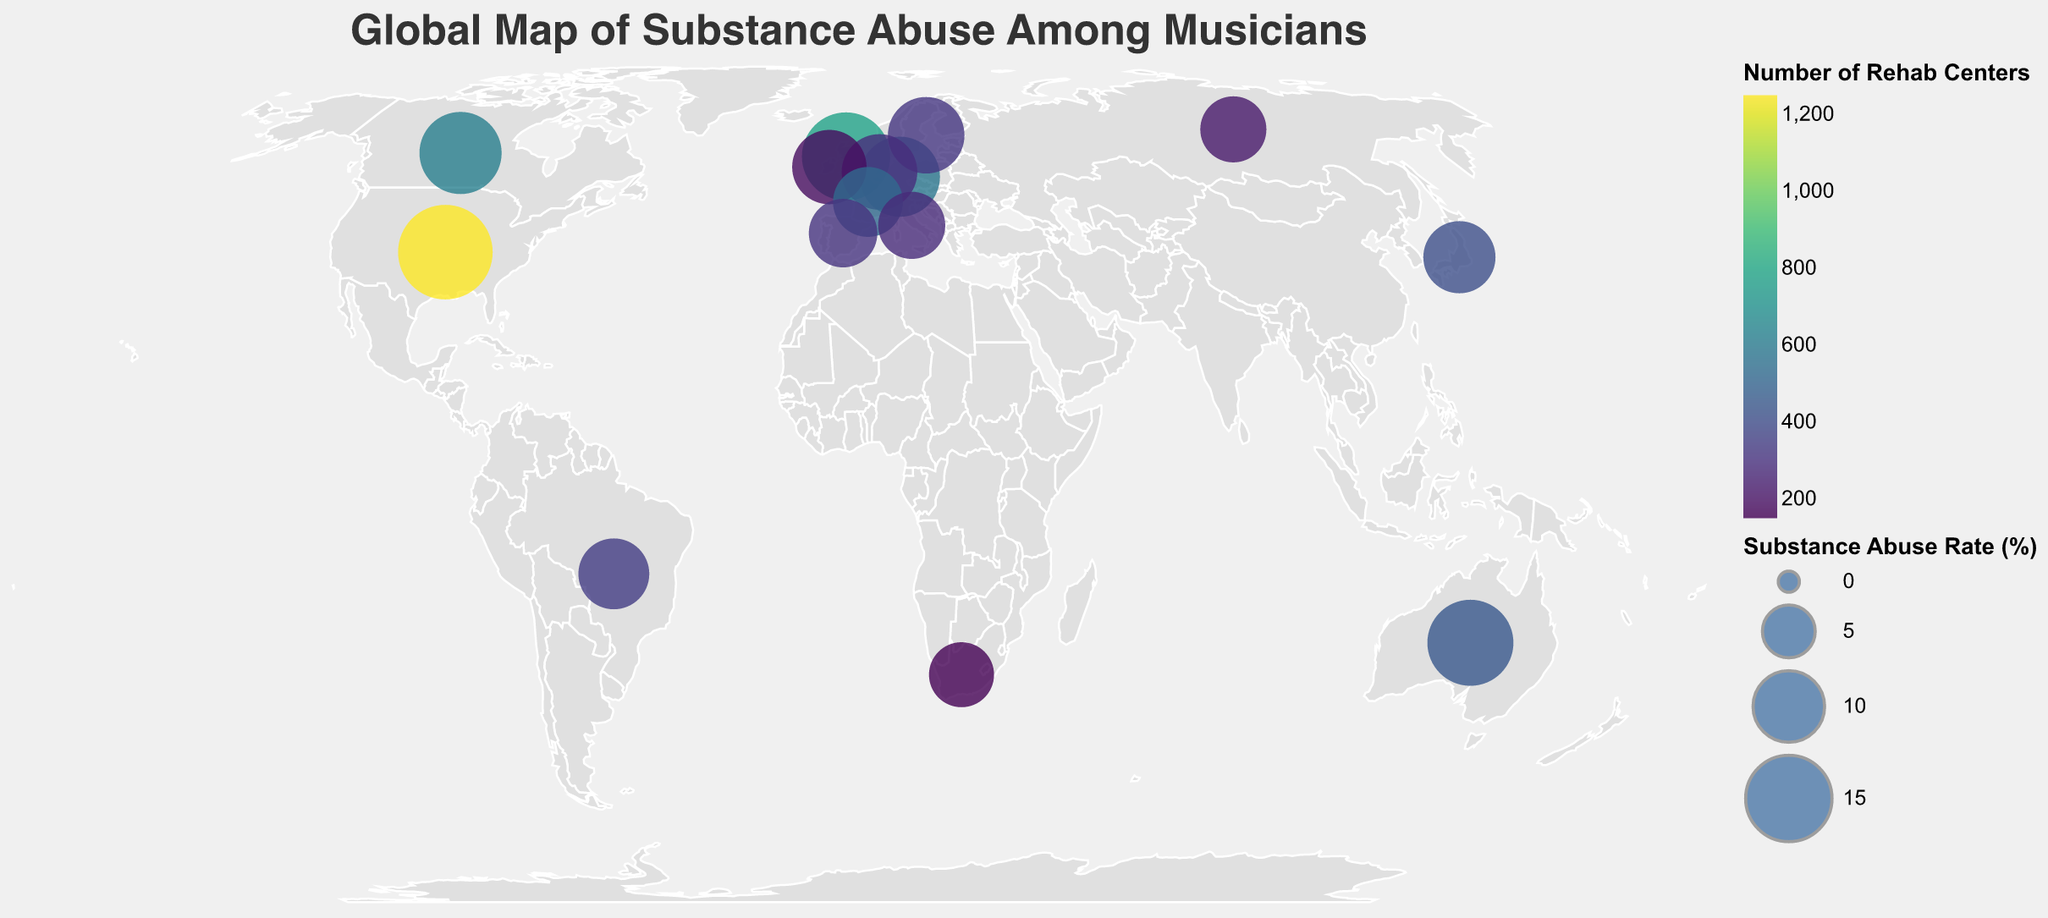What is the title of the figure? The title is usually located at the top of the figure, and it is meant to provide a concise summary of what the figure represents. Look at the top center to find it.
Answer: Global Map of Substance Abuse Among Musicians Which country has the highest substance abuse rate among musicians? Identify the country with the largest circle, which represents a higher substance abuse rate. The tooltip provides detailed information when hovering over each circle.
Answer: United States How many rehab centers are there in Germany according to the map? Find Germany on the map, hover over or refer to its circle to see the tooltip, which lists the number of rehab centers along with other details.
Answer: 580 Compare the substance abuse rates of the United Kingdom and Australia. Which country has a higher rate? Look at the circle sizes for both the United Kingdom and Australia. Refer to the tooltip for precise values if needed.
Answer: United Kingdom What is the relationship between the number of rehab centers and substance abuse rate in the United States? Observe the tooltip for the circle representing the United States to check both the substance abuse rate and the number of rehab centers, and analyze if there is any visible correlation.
Answer: The United States has a high substance abuse rate (18.2%) and a large number of rehab centers (1250) Which region (Europe or Americas) has a higher average substance abuse rate among musicians based on the given countries? Identify the countries in the data that belong to Europe (UK, Germany, Sweden, Netherlands, Ireland, France, Spain, Italy, Russia) and the Americas (US, Canada, Brazil), then calculate and compare the averages for these regions.
Answer: Europe In which country does Tokyo represent the notable music scene with a substance abuse rate of 10.2%? Find the tooltip that lists "Tokyo" as the notable music scene and check the corresponding country and its substance abuse rate.
Answer: Japan Which European country has the lowest substance abuse rate among musicians on the map? Focus on European countries by looking at their circle sizes and using the tooltips to find the lowest rate.
Answer: Russia What can you infer about the correlation between the number of rehab centers and substance abuse rates in the countries displayed? Analyze the circles‘ colors and sizes; a larger circle size represents a higher substance abuse rate, and color intensity represents the number of rehab centers. Determine if there seems to be a pattern where higher rates correlate with more rehab centers or vice versa.
Answer: Higher substance abuse rates often correlate with more rehab centers 